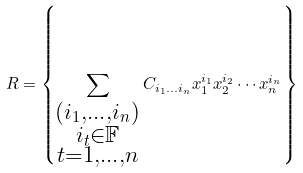Convert formula to latex. <formula><loc_0><loc_0><loc_500><loc_500>R = \left \{ \sum _ { \substack { ( i _ { 1 } , \dots , i _ { n } ) \\ i _ { t } \in \mathbb { F } \\ t = 1 , \dots , n } } C _ { i _ { 1 } \dots i _ { n } } x ^ { i _ { 1 } } _ { 1 } x ^ { i _ { 2 } } _ { 2 } \cdots x ^ { i _ { n } } _ { n } \right \}</formula> 